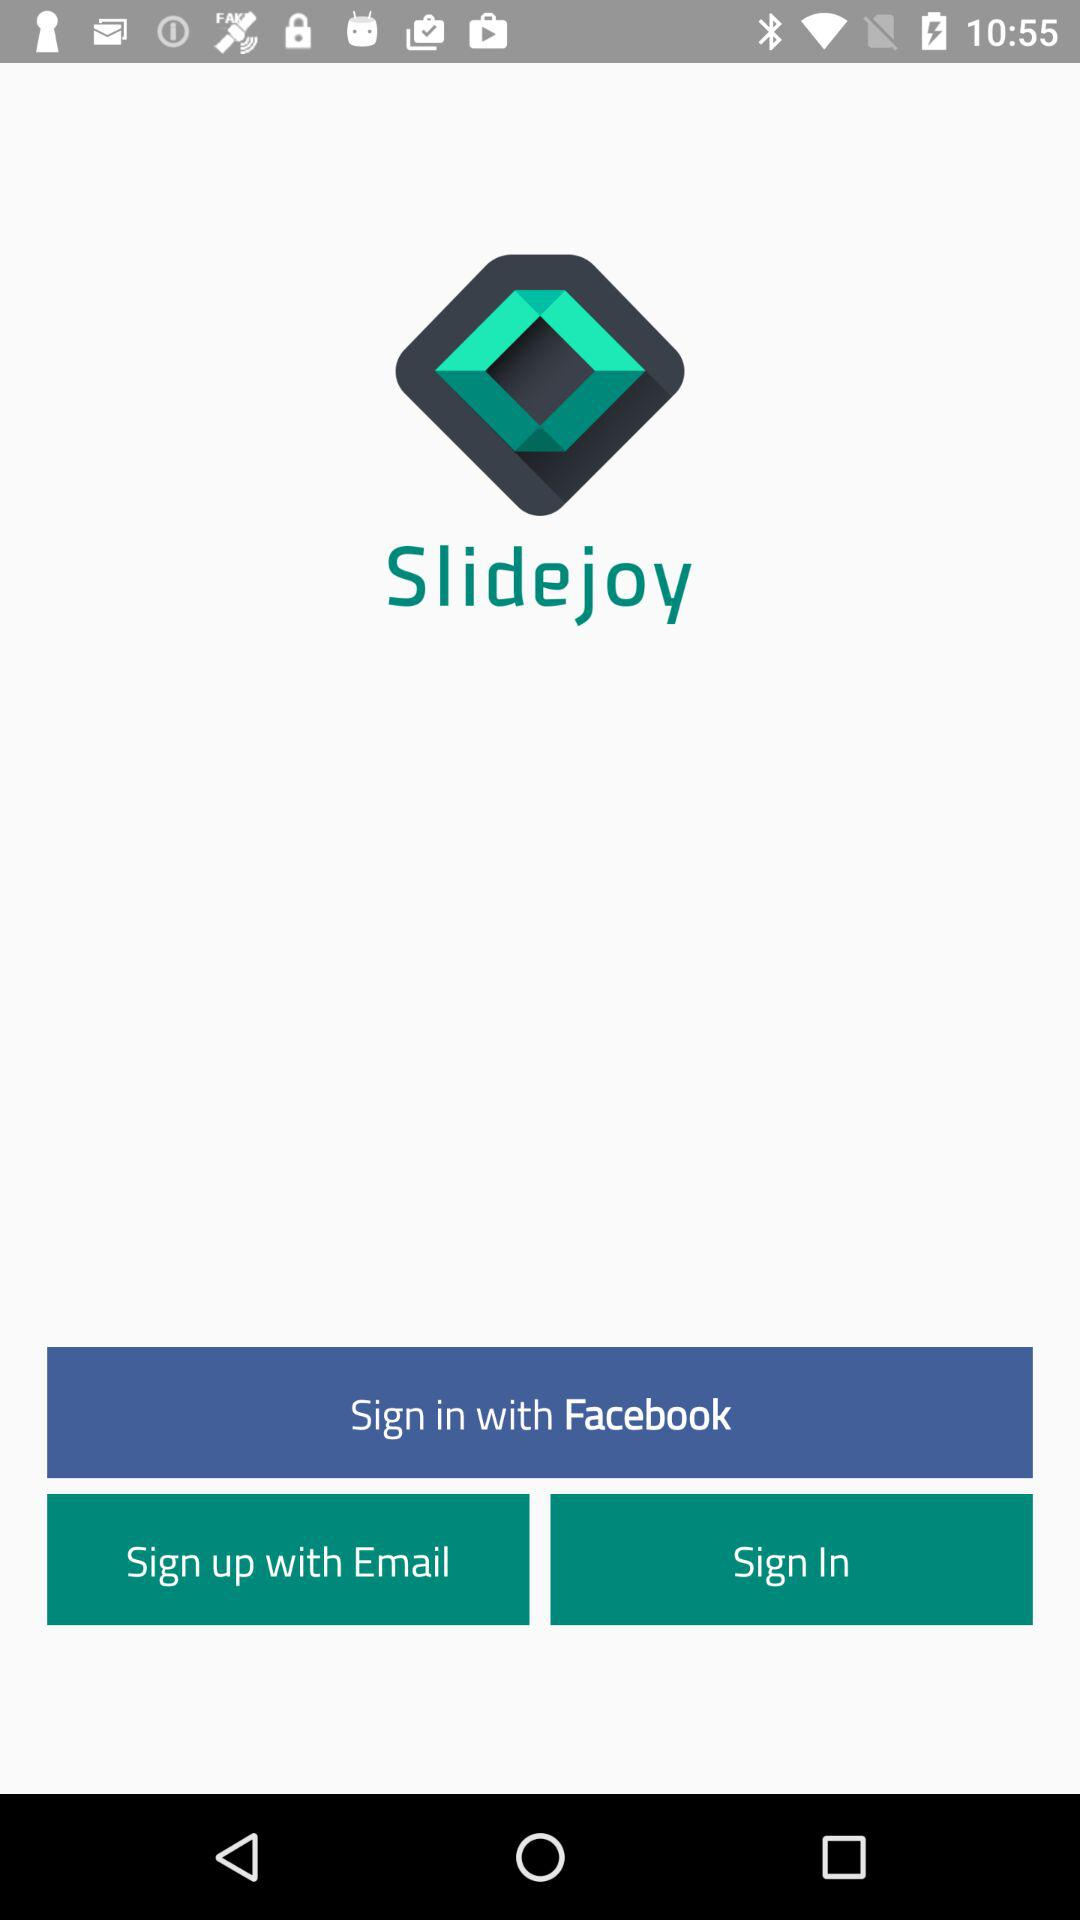Which are the different login options? The different login options are "Facebook" and "Email". 